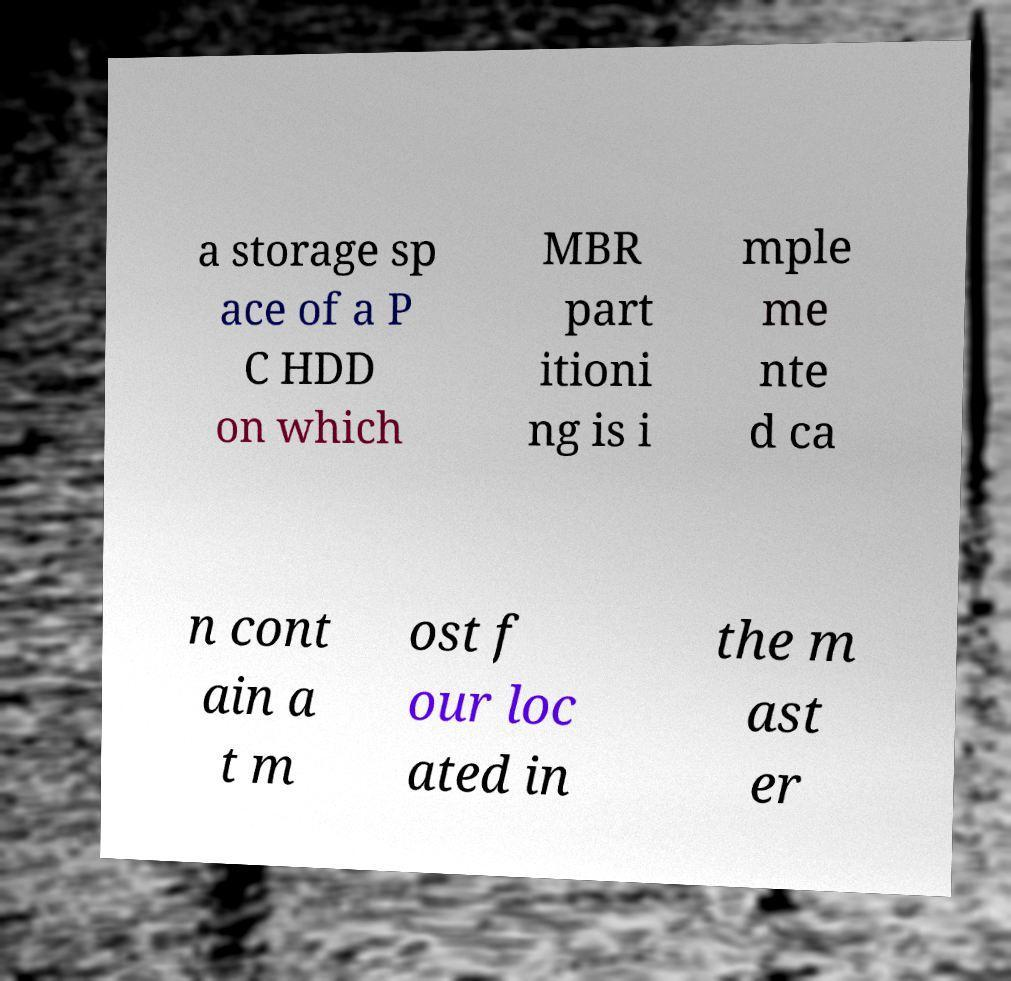For documentation purposes, I need the text within this image transcribed. Could you provide that? a storage sp ace of a P C HDD on which MBR part itioni ng is i mple me nte d ca n cont ain a t m ost f our loc ated in the m ast er 